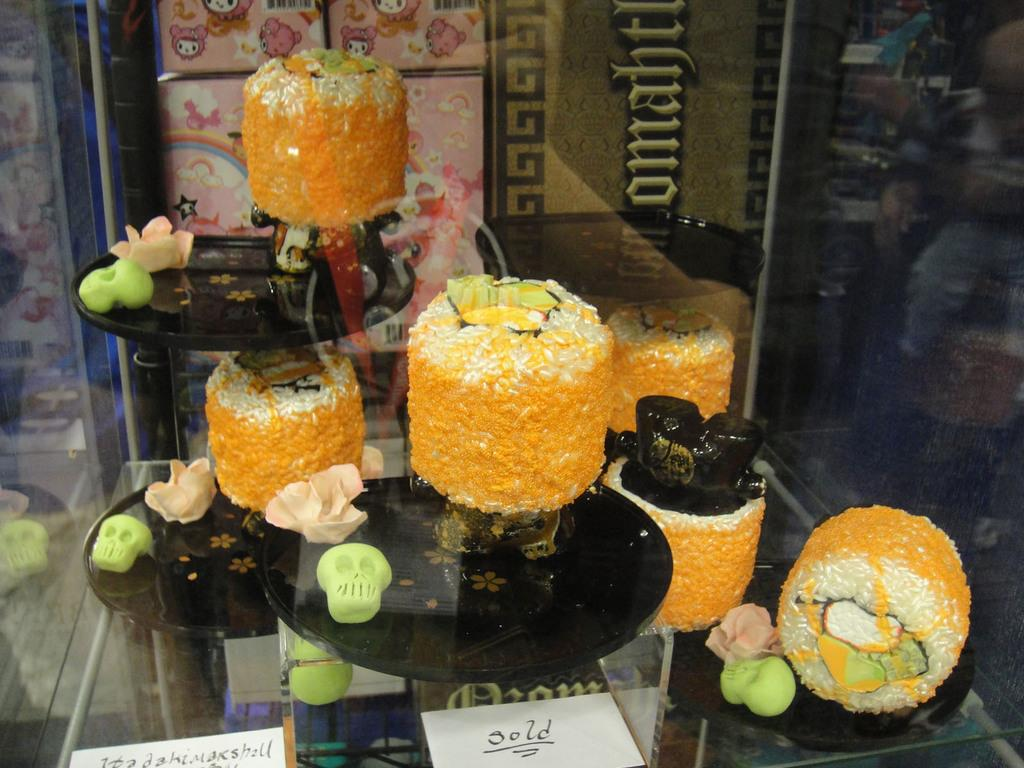What can be seen in the image? There are objects in the image. Where are the objects located? The objects are in a glass. What can be observed about the colors of the objects? The objects have different colors, including orange. What type of weather is depicted in the image? There is no weather depicted in the image, as it features objects in a glass. How many pigs are visible in the image? There are no pigs present in the image. 